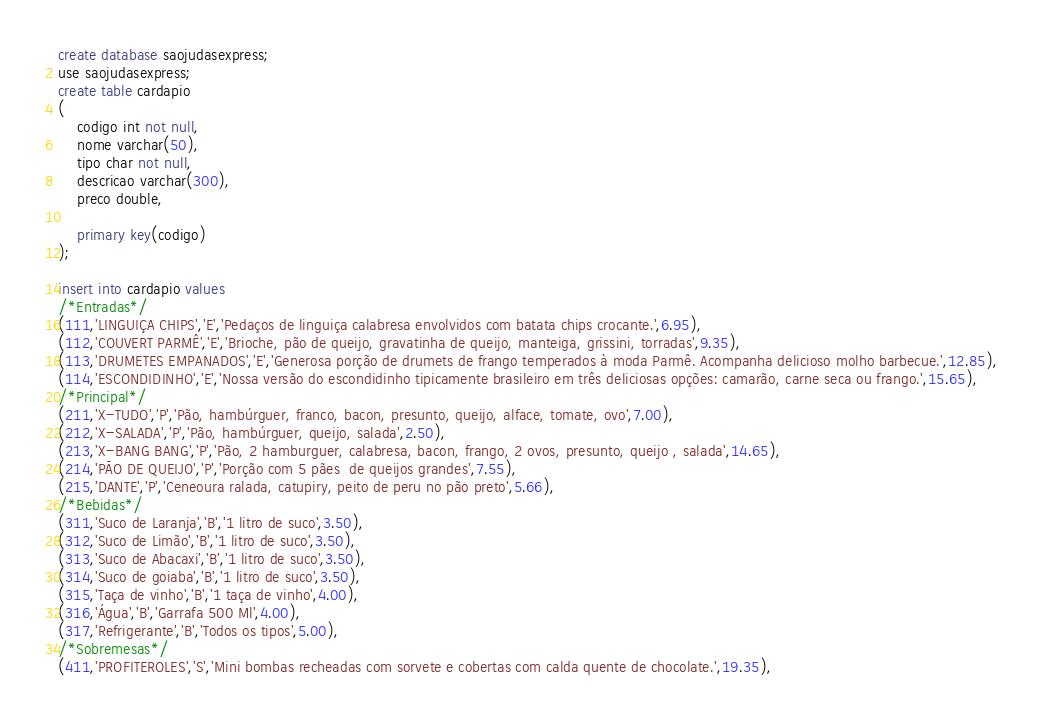Convert code to text. <code><loc_0><loc_0><loc_500><loc_500><_SQL_>create database saojudasexpress;
use saojudasexpress;
create table cardapio
(
	codigo int not null,
    nome varchar(50),
    tipo char not null,
    descricao varchar(300),
    preco double,
    
    primary key(codigo)
);

insert into cardapio values 
/*Entradas*/
(111,'LINGUIÇA CHIPS','E','Pedaços de linguiça calabresa envolvidos com batata chips crocante.',6.95),
(112,'COUVERT PARMÊ','E','Brioche, pão de queijo, gravatinha de queijo, manteiga, grissini, torradas',9.35),
(113,'DRUMETES EMPANADOS','E','Generosa porção de drumets de frango temperados à moda Parmê. Acompanha delicioso molho barbecue.',12.85),
(114,'ESCONDIDINHO','E','Nossa versão do escondidinho tipicamente brasileiro em três deliciosas opções: camarão, carne seca ou frango.',15.65),
/*Principal*/
(211,'X-TUDO','P','Pão, hambúrguer, franco, bacon, presunto, queijo, alface, tomate, ovo',7.00),
(212,'X-SALADA','P','Pão, hambúrguer, queijo, salada',2.50),
(213,'X-BANG BANG','P','Pão, 2 hamburguer, calabresa, bacon, frango, 2 ovos, presunto, queijo , salada',14.65),
(214,'PÃO DE QUEIJO','P','Porção com 5 pães  de queijos grandes',7.55),
(215,'DANTE','P','Ceneoura ralada, catupiry, peito de peru no pão preto',5.66),
/*Bebidas*/
(311,'Suco de Laranja','B','1 litro de suco',3.50),
(312,'Suco de Limão','B','1 litro de suco',3.50),
(313,'Suco de Abacaxi','B','1 litro de suco',3.50),
(314,'Suco de goiaba','B','1 litro de suco',3.50),
(315,'Taça de vinho','B','1 taça de vinho',4.00),
(316,'Água','B','Garrafa 500 Ml',4.00),
(317,'Refrigerante','B','Todos os tipos',5.00),
/*Sobremesas*/ 
(411,'PROFITEROLES','S','Mini bombas recheadas com sorvete e cobertas com calda quente de chocolate.',19.35),</code> 